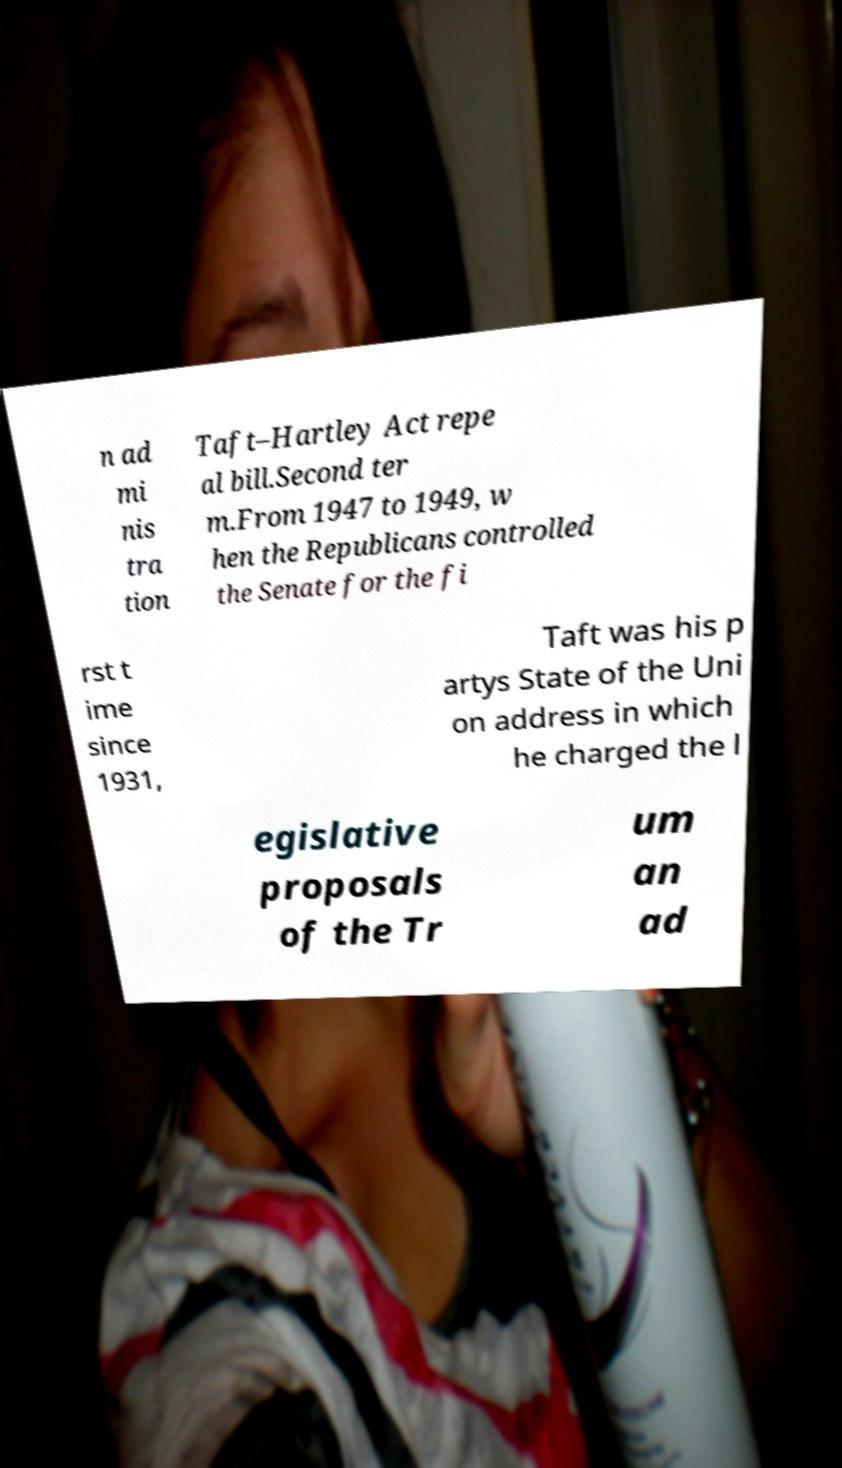Can you accurately transcribe the text from the provided image for me? n ad mi nis tra tion Taft–Hartley Act repe al bill.Second ter m.From 1947 to 1949, w hen the Republicans controlled the Senate for the fi rst t ime since 1931, Taft was his p artys State of the Uni on address in which he charged the l egislative proposals of the Tr um an ad 